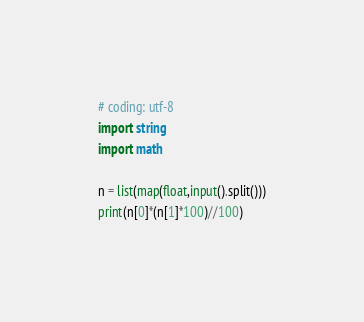Convert code to text. <code><loc_0><loc_0><loc_500><loc_500><_Python_># coding: utf-8
import string
import math

n = list(map(float,input().split()))
print(n[0]*(n[1]*100)//100)</code> 